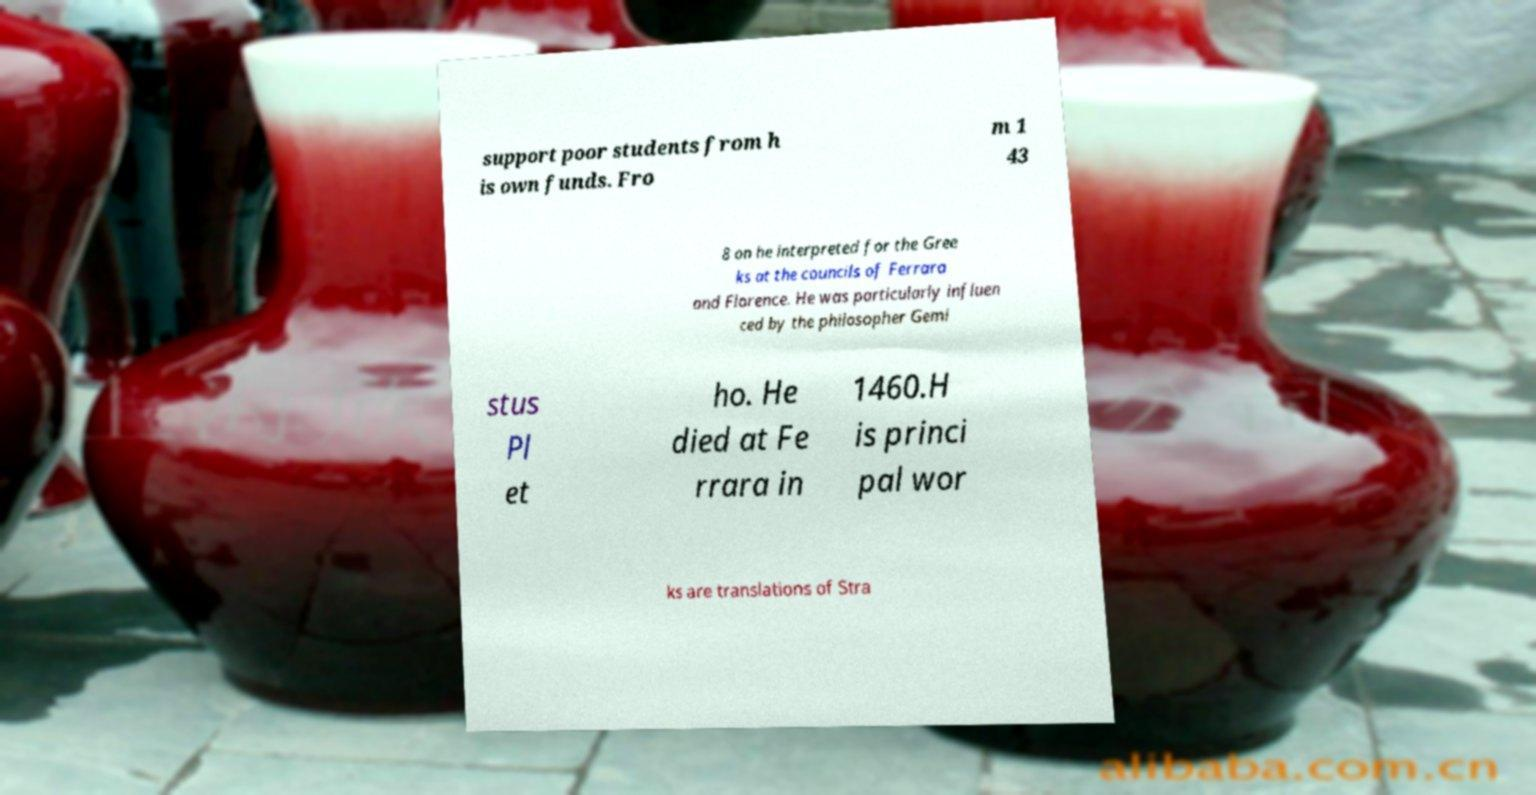Please read and relay the text visible in this image. What does it say? support poor students from h is own funds. Fro m 1 43 8 on he interpreted for the Gree ks at the councils of Ferrara and Florence. He was particularly influen ced by the philosopher Gemi stus Pl et ho. He died at Fe rrara in 1460.H is princi pal wor ks are translations of Stra 